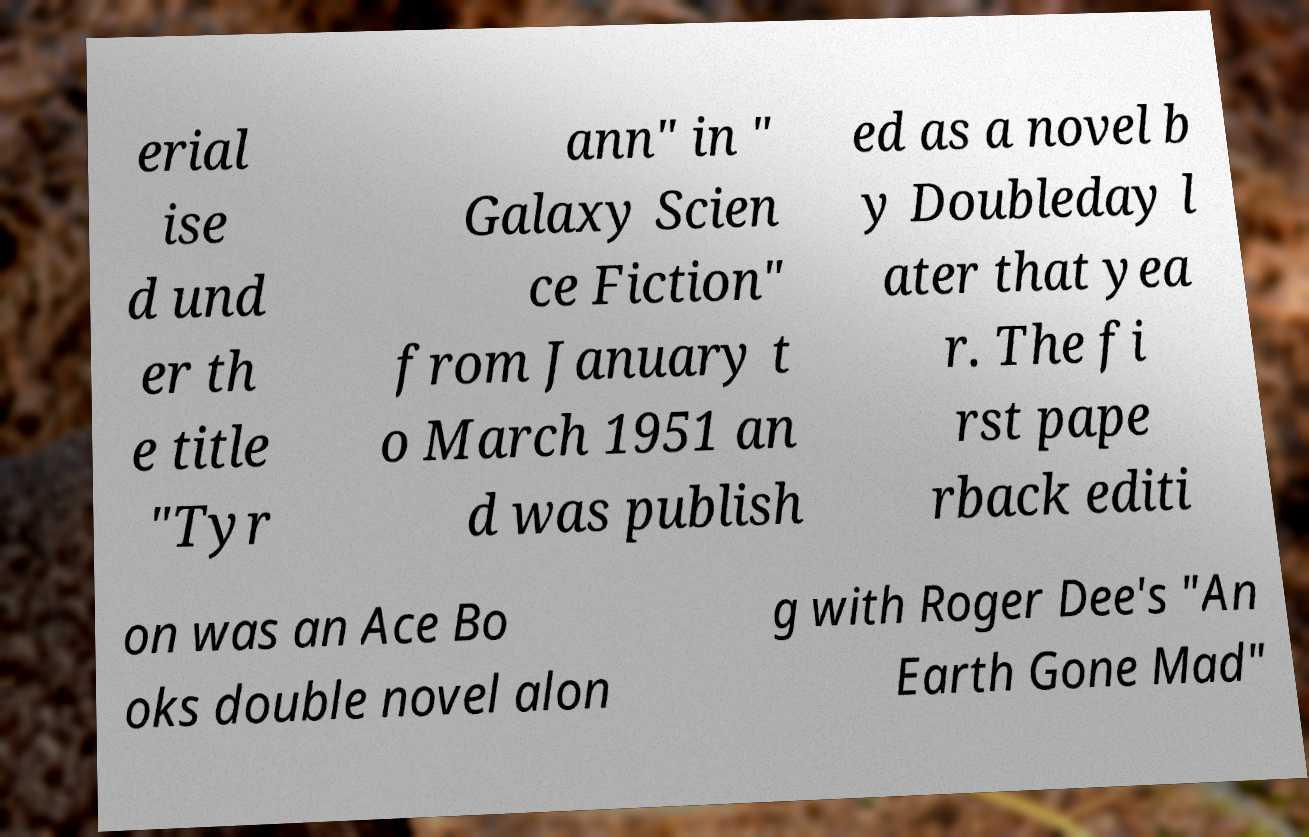For documentation purposes, I need the text within this image transcribed. Could you provide that? erial ise d und er th e title "Tyr ann" in " Galaxy Scien ce Fiction" from January t o March 1951 an d was publish ed as a novel b y Doubleday l ater that yea r. The fi rst pape rback editi on was an Ace Bo oks double novel alon g with Roger Dee's "An Earth Gone Mad" 